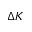<formula> <loc_0><loc_0><loc_500><loc_500>\Delta K</formula> 